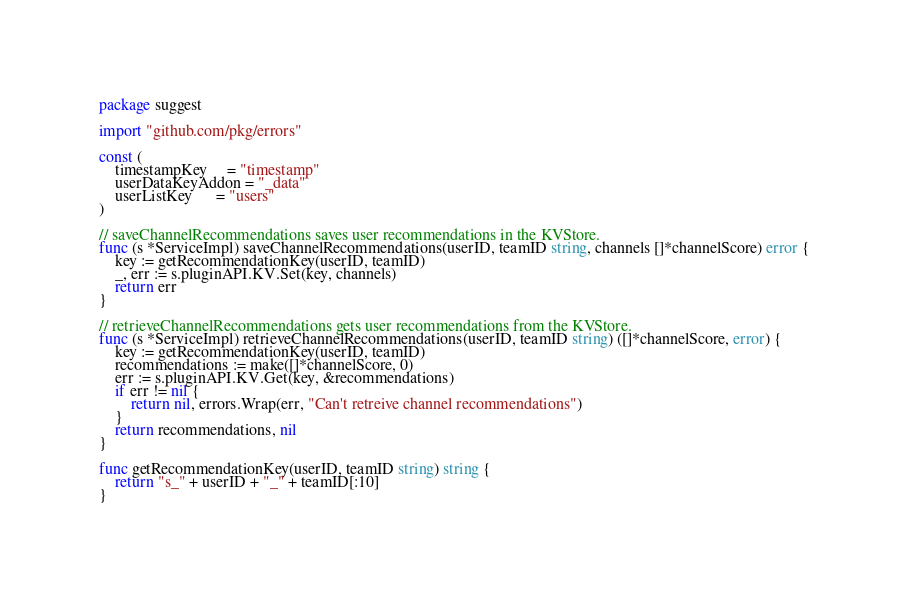<code> <loc_0><loc_0><loc_500><loc_500><_Go_>package suggest

import "github.com/pkg/errors"

const (
	timestampKey     = "timestamp"
	userDataKeyAddon = "_data"
	userListKey      = "users"
)

// saveChannelRecommendations saves user recommendations in the KVStore.
func (s *ServiceImpl) saveChannelRecommendations(userID, teamID string, channels []*channelScore) error {
	key := getRecommendationKey(userID, teamID)
	_, err := s.pluginAPI.KV.Set(key, channels)
	return err
}

// retrieveChannelRecommendations gets user recommendations from the KVStore.
func (s *ServiceImpl) retrieveChannelRecommendations(userID, teamID string) ([]*channelScore, error) {
	key := getRecommendationKey(userID, teamID)
	recommendations := make([]*channelScore, 0)
	err := s.pluginAPI.KV.Get(key, &recommendations)
	if err != nil {
		return nil, errors.Wrap(err, "Can't retreive channel recommendations")
	}
	return recommendations, nil
}

func getRecommendationKey(userID, teamID string) string {
	return "s_" + userID + "_" + teamID[:10]
}
</code> 